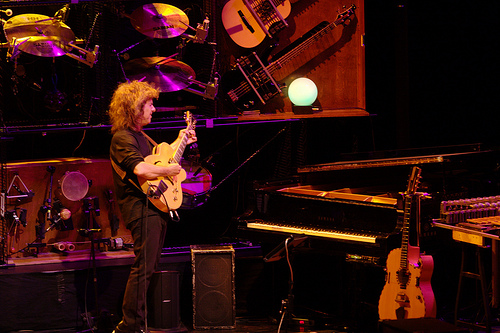<image>
Is the tambourine behind the guitarist? Yes. From this viewpoint, the tambourine is positioned behind the guitarist, with the guitarist partially or fully occluding the tambourine. 